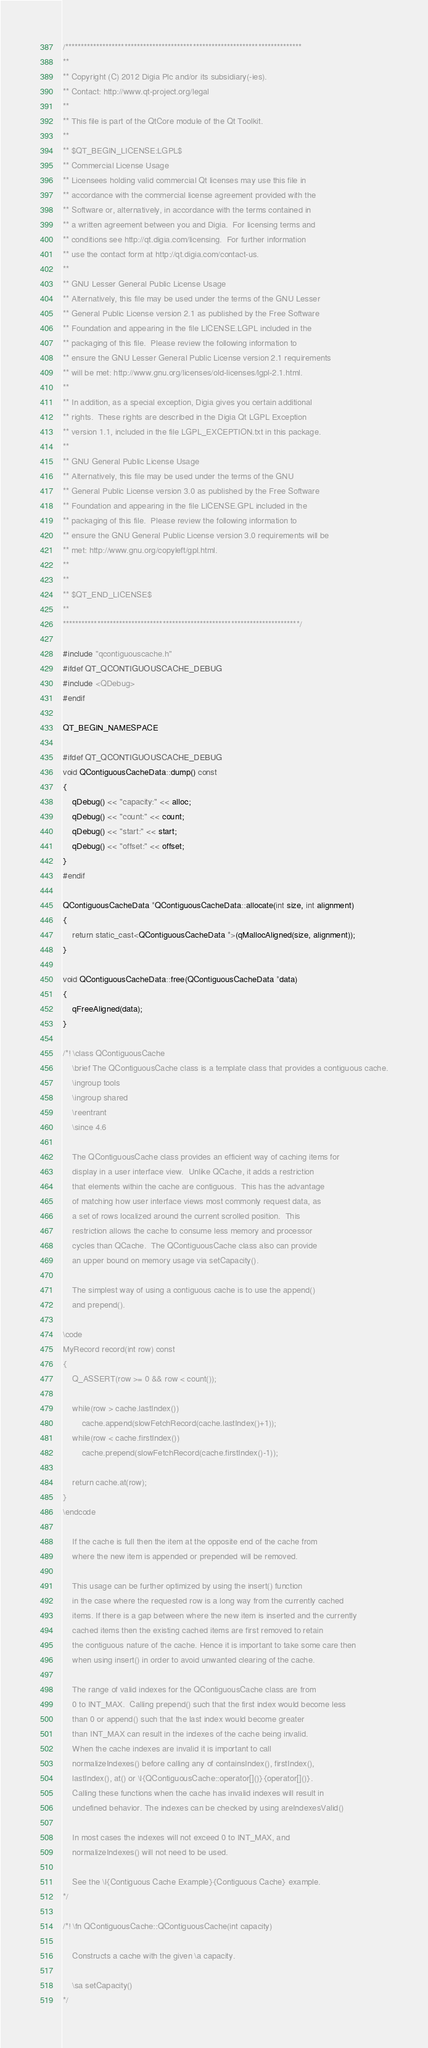<code> <loc_0><loc_0><loc_500><loc_500><_C++_>/****************************************************************************
**
** Copyright (C) 2012 Digia Plc and/or its subsidiary(-ies).
** Contact: http://www.qt-project.org/legal
**
** This file is part of the QtCore module of the Qt Toolkit.
**
** $QT_BEGIN_LICENSE:LGPL$
** Commercial License Usage
** Licensees holding valid commercial Qt licenses may use this file in
** accordance with the commercial license agreement provided with the
** Software or, alternatively, in accordance with the terms contained in
** a written agreement between you and Digia.  For licensing terms and
** conditions see http://qt.digia.com/licensing.  For further information
** use the contact form at http://qt.digia.com/contact-us.
**
** GNU Lesser General Public License Usage
** Alternatively, this file may be used under the terms of the GNU Lesser
** General Public License version 2.1 as published by the Free Software
** Foundation and appearing in the file LICENSE.LGPL included in the
** packaging of this file.  Please review the following information to
** ensure the GNU Lesser General Public License version 2.1 requirements
** will be met: http://www.gnu.org/licenses/old-licenses/lgpl-2.1.html.
**
** In addition, as a special exception, Digia gives you certain additional
** rights.  These rights are described in the Digia Qt LGPL Exception
** version 1.1, included in the file LGPL_EXCEPTION.txt in this package.
**
** GNU General Public License Usage
** Alternatively, this file may be used under the terms of the GNU
** General Public License version 3.0 as published by the Free Software
** Foundation and appearing in the file LICENSE.GPL included in the
** packaging of this file.  Please review the following information to
** ensure the GNU General Public License version 3.0 requirements will be
** met: http://www.gnu.org/copyleft/gpl.html.
**
**
** $QT_END_LICENSE$
**
****************************************************************************/

#include "qcontiguouscache.h"
#ifdef QT_QCONTIGUOUSCACHE_DEBUG
#include <QDebug>
#endif

QT_BEGIN_NAMESPACE

#ifdef QT_QCONTIGUOUSCACHE_DEBUG
void QContiguousCacheData::dump() const
{
    qDebug() << "capacity:" << alloc;
    qDebug() << "count:" << count;
    qDebug() << "start:" << start;
    qDebug() << "offset:" << offset;
}
#endif

QContiguousCacheData *QContiguousCacheData::allocate(int size, int alignment)
{
    return static_cast<QContiguousCacheData *>(qMallocAligned(size, alignment));
}

void QContiguousCacheData::free(QContiguousCacheData *data)
{
    qFreeAligned(data);
}

/*! \class QContiguousCache
    \brief The QContiguousCache class is a template class that provides a contiguous cache.
    \ingroup tools
    \ingroup shared
    \reentrant
    \since 4.6

    The QContiguousCache class provides an efficient way of caching items for
    display in a user interface view.  Unlike QCache, it adds a restriction
    that elements within the cache are contiguous.  This has the advantage
    of matching how user interface views most commonly request data, as
    a set of rows localized around the current scrolled position.  This
    restriction allows the cache to consume less memory and processor
    cycles than QCache.  The QContiguousCache class also can provide
    an upper bound on memory usage via setCapacity().

    The simplest way of using a contiguous cache is to use the append()
    and prepend().

\code
MyRecord record(int row) const
{
    Q_ASSERT(row >= 0 && row < count());

    while(row > cache.lastIndex())
        cache.append(slowFetchRecord(cache.lastIndex()+1));
    while(row < cache.firstIndex())
        cache.prepend(slowFetchRecord(cache.firstIndex()-1));

    return cache.at(row);
}
\endcode

    If the cache is full then the item at the opposite end of the cache from
    where the new item is appended or prepended will be removed.

    This usage can be further optimized by using the insert() function
    in the case where the requested row is a long way from the currently cached
    items. If there is a gap between where the new item is inserted and the currently
    cached items then the existing cached items are first removed to retain
    the contiguous nature of the cache. Hence it is important to take some care then
    when using insert() in order to avoid unwanted clearing of the cache.

    The range of valid indexes for the QContiguousCache class are from
    0 to INT_MAX.  Calling prepend() such that the first index would become less
    than 0 or append() such that the last index would become greater
    than INT_MAX can result in the indexes of the cache being invalid.
    When the cache indexes are invalid it is important to call
    normalizeIndexes() before calling any of containsIndex(), firstIndex(),
    lastIndex(), at() or \l{QContiguousCache::operator[]()}{operator[]()}.
    Calling these functions when the cache has invalid indexes will result in
    undefined behavior. The indexes can be checked by using areIndexesValid()

    In most cases the indexes will not exceed 0 to INT_MAX, and
    normalizeIndexes() will not need to be used.

    See the \l{Contiguous Cache Example}{Contiguous Cache} example.
*/

/*! \fn QContiguousCache::QContiguousCache(int capacity)

    Constructs a cache with the given \a capacity.

    \sa setCapacity()
*/
</code> 